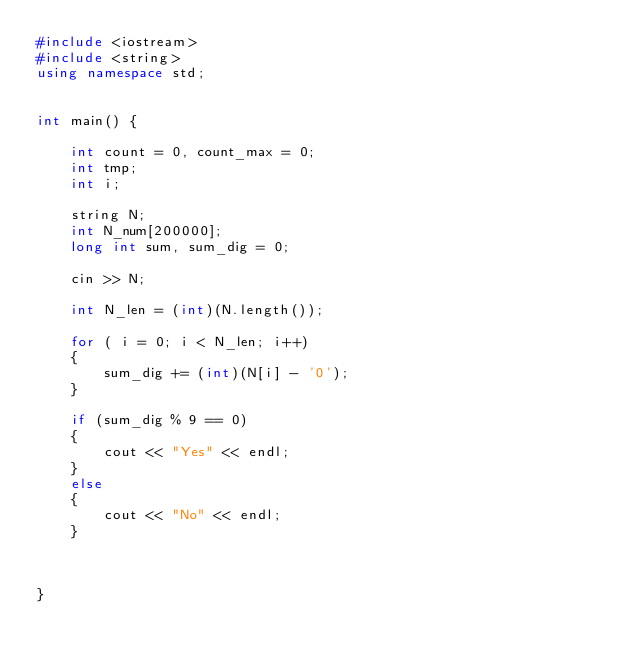Convert code to text. <code><loc_0><loc_0><loc_500><loc_500><_C++_>#include <iostream>
#include <string>
using namespace std;


int main() {

	int count = 0, count_max = 0;
	int tmp;
	int i;

	string N;
	int N_num[200000];
	long int sum, sum_dig = 0;

	cin >> N;

	int N_len = (int)(N.length());

	for ( i = 0; i < N_len; i++)
	{
		sum_dig += (int)(N[i] - '0');
	}
	
	if (sum_dig % 9 == 0)
	{
		cout << "Yes" << endl;
	}
	else
	{
		cout << "No" << endl;
	}
		
	
	
}</code> 